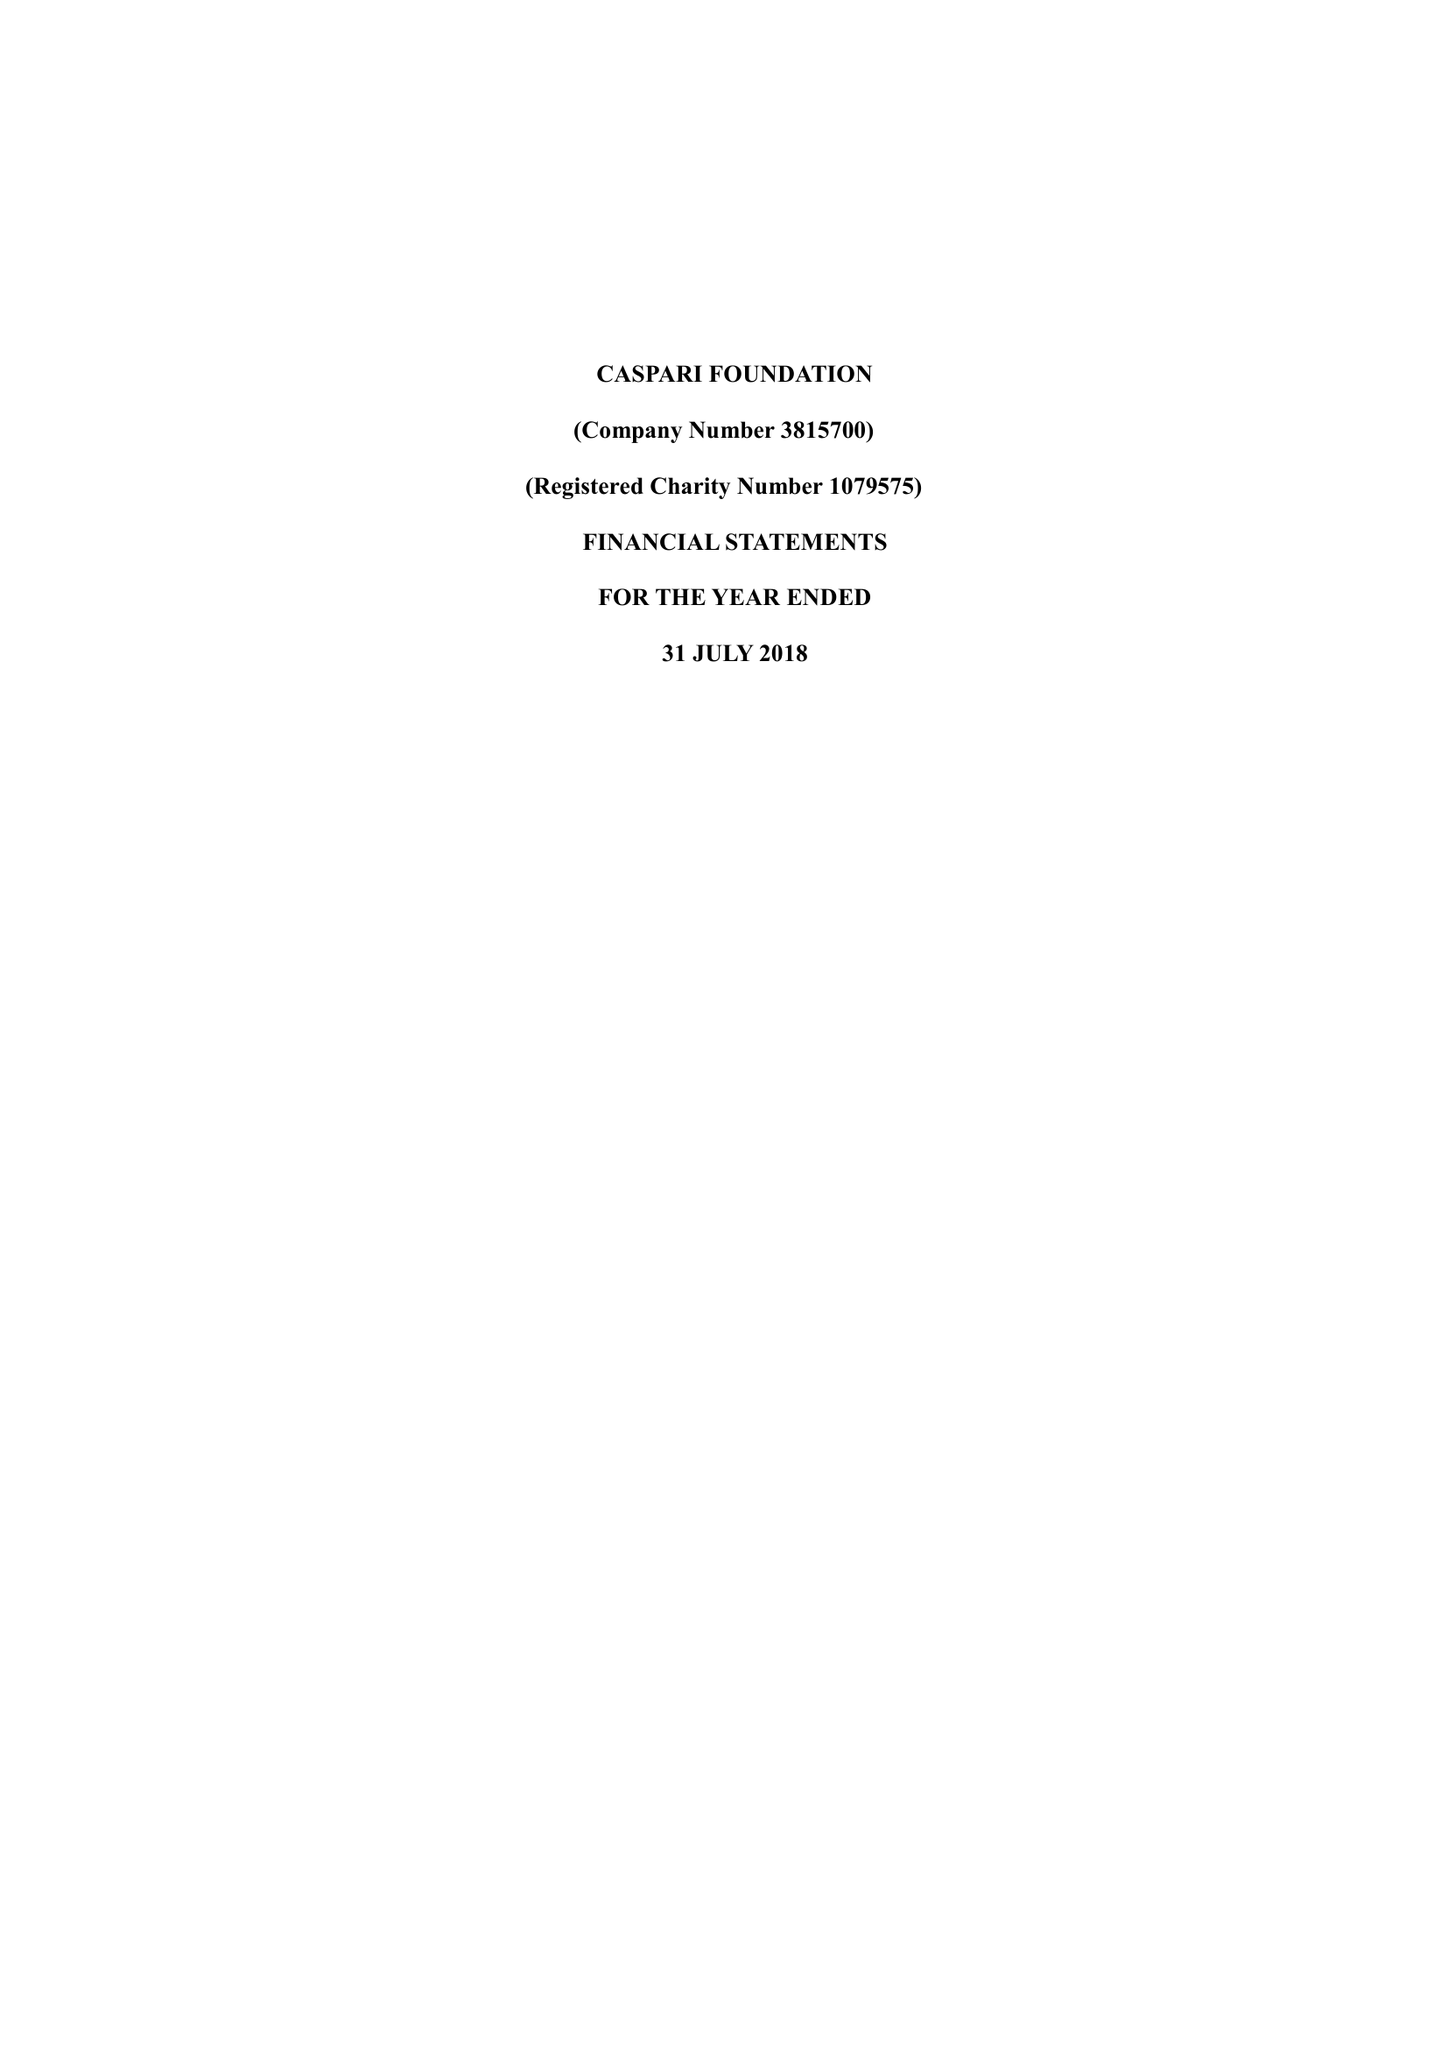What is the value for the address__postcode?
Answer the question using a single word or phrase. N4 2DA 